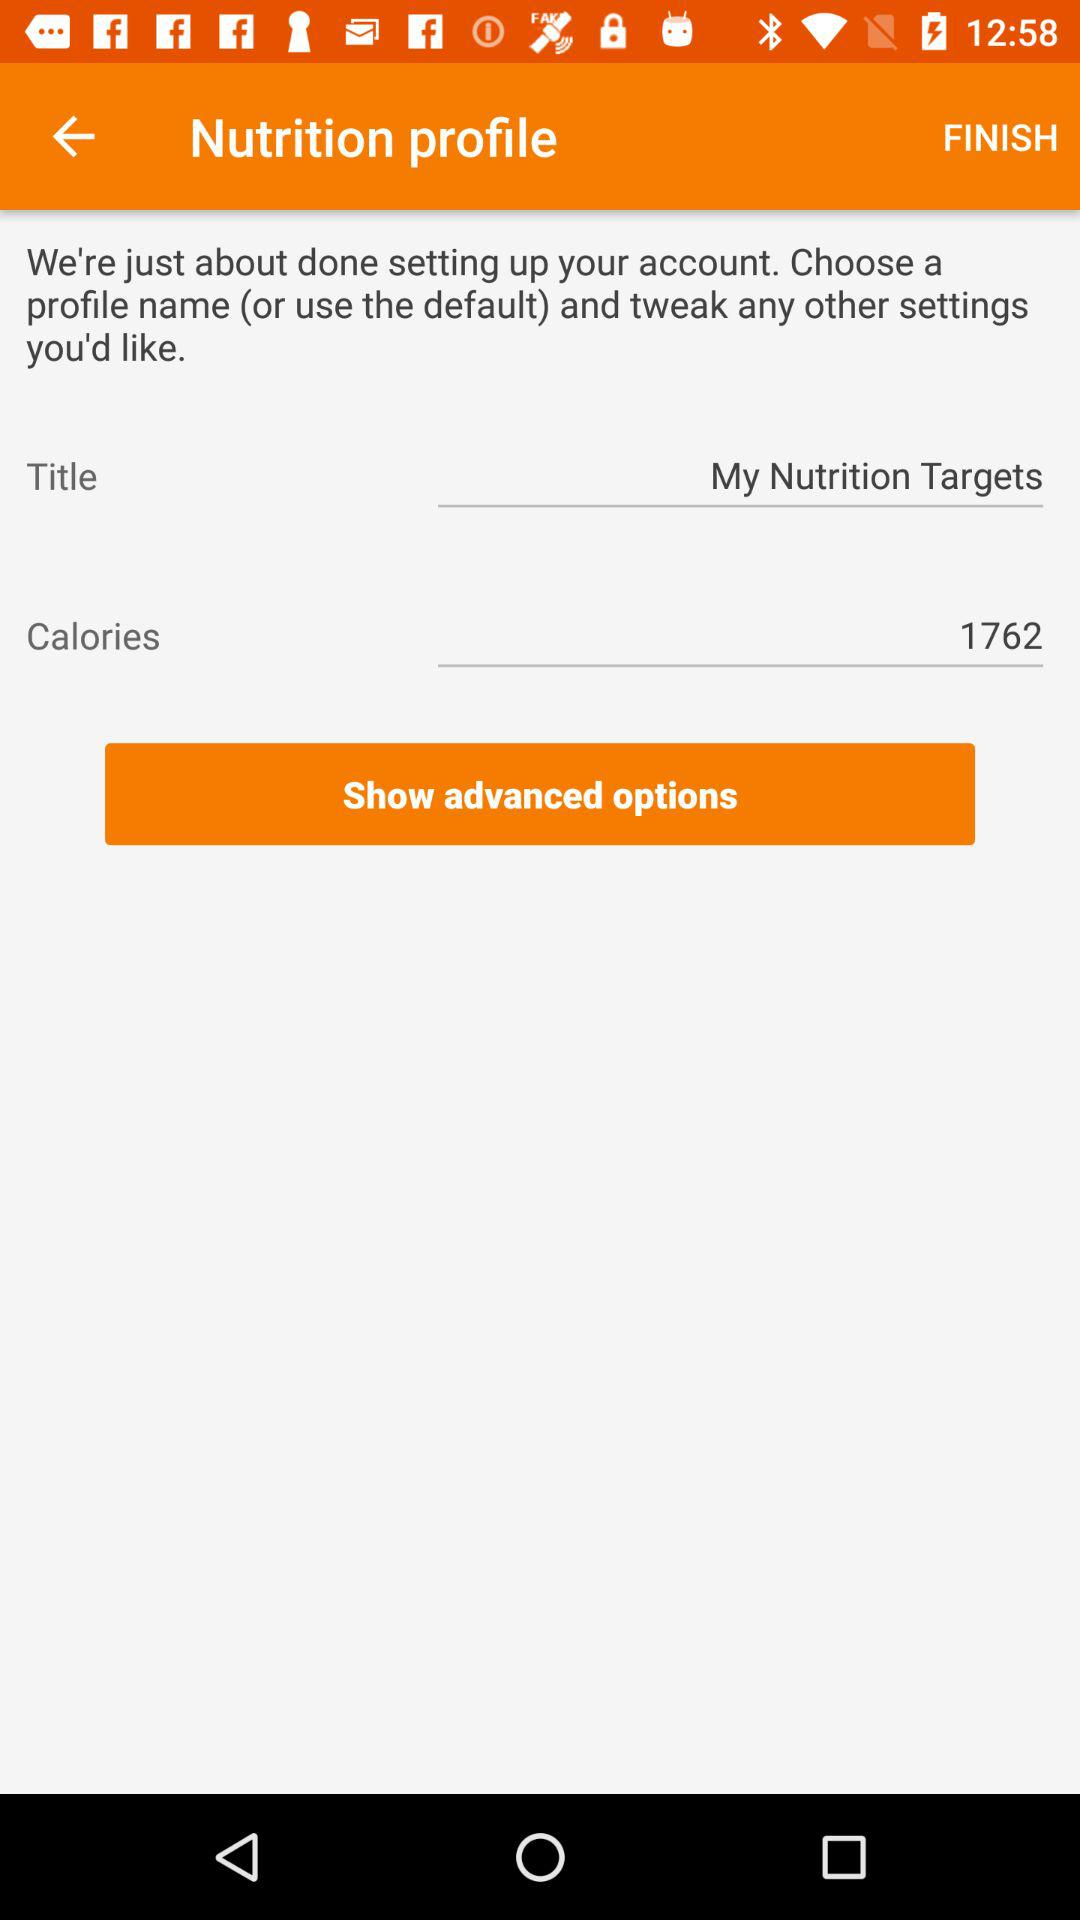What is the title? The title is "My Nutrition Targets". 